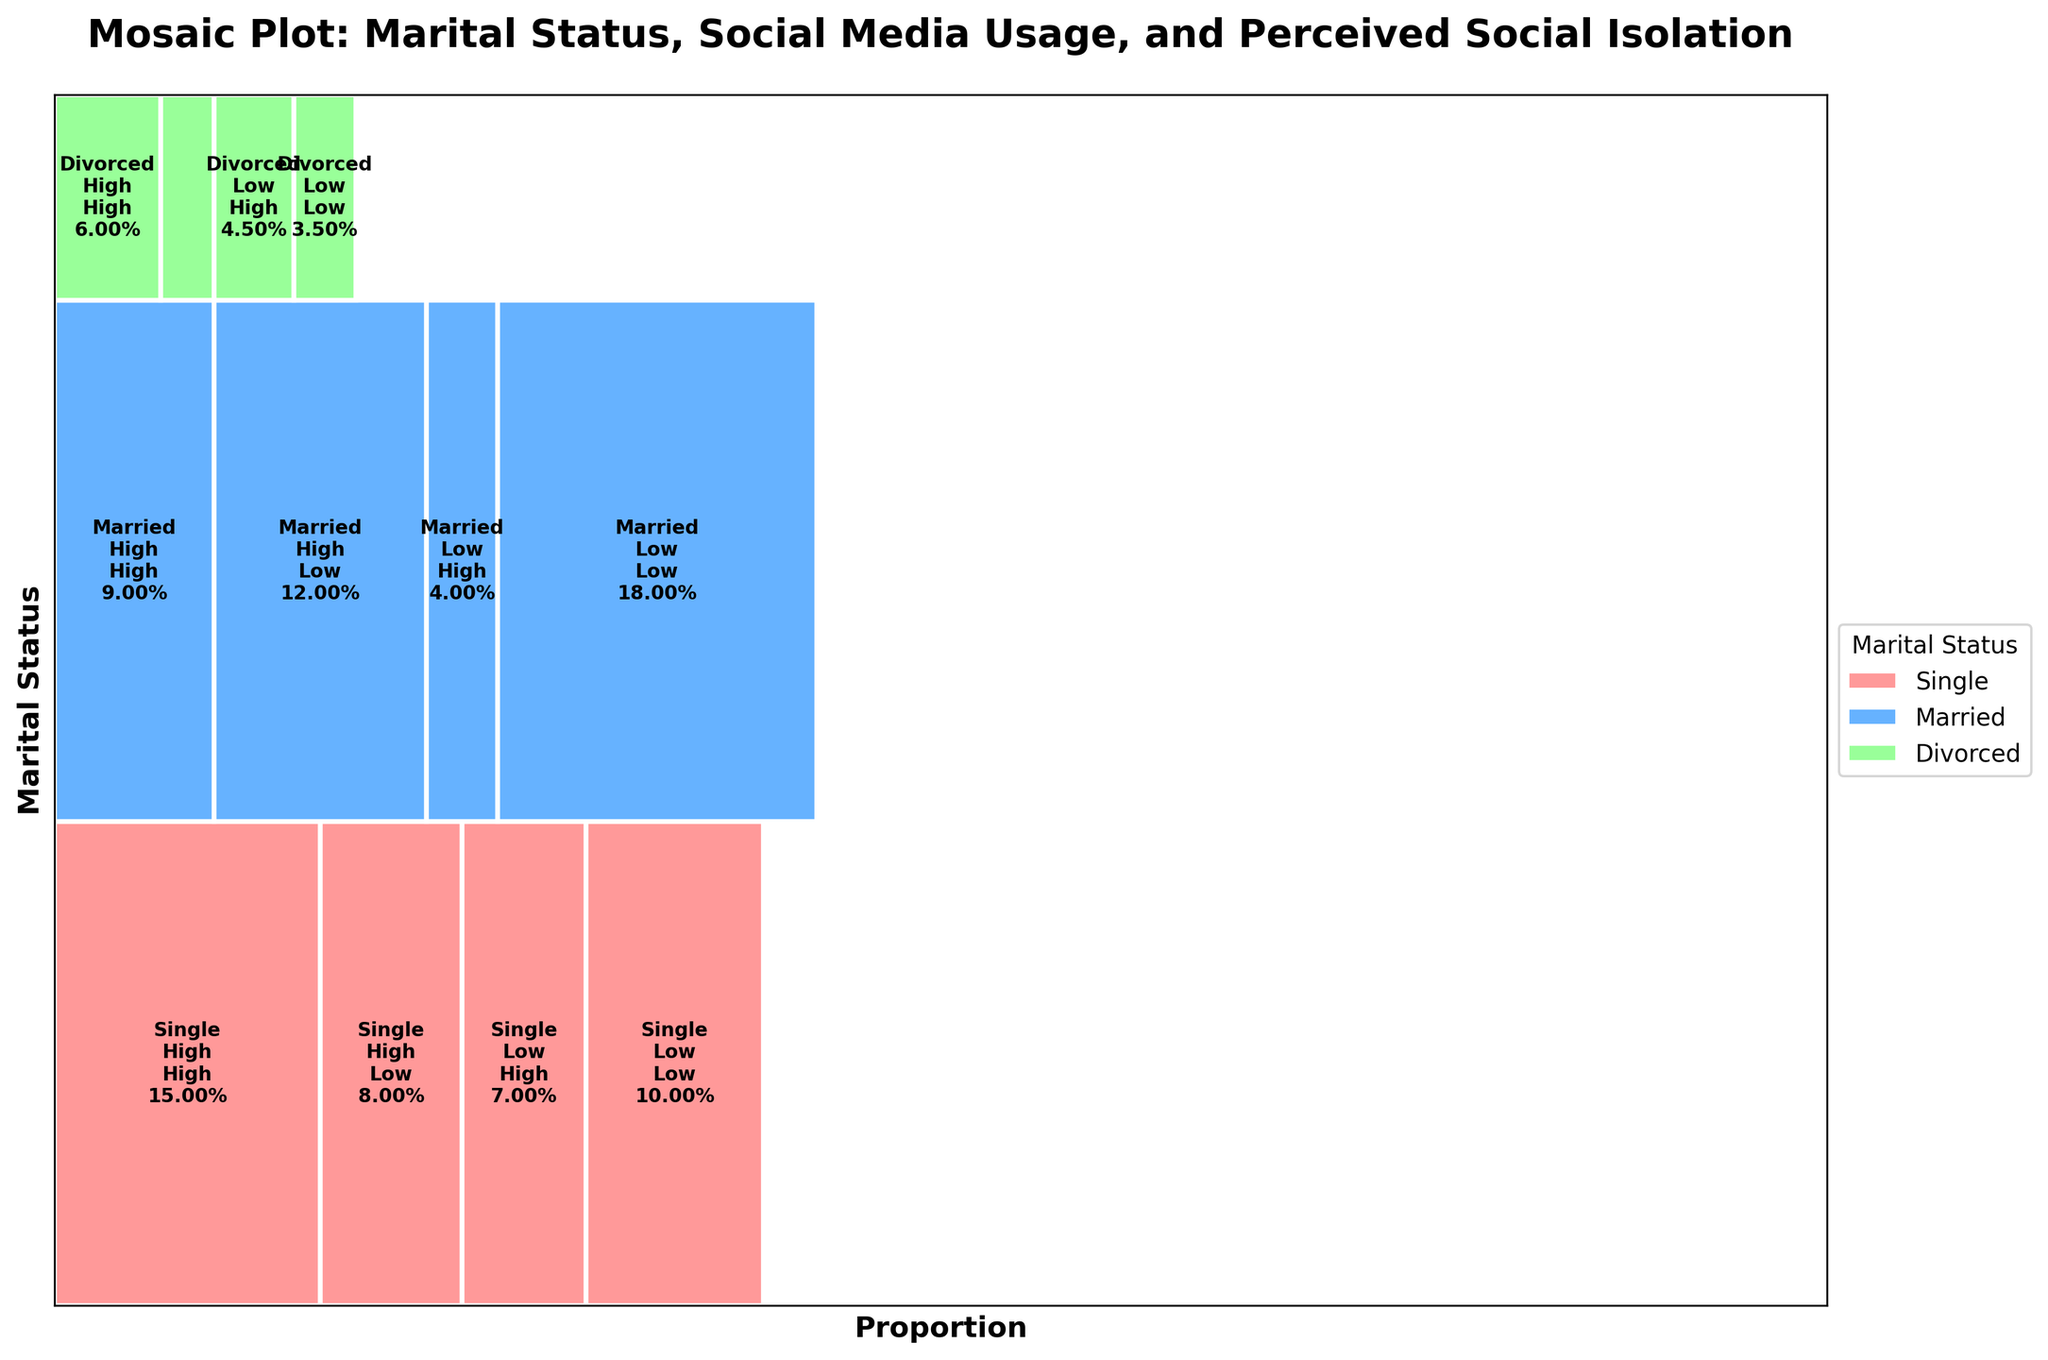What is the title of the plot? The title of the plot is displayed at the top and reads "Mosaic Plot: Marital Status, Social Media Usage, and Perceived Social Isolation".
Answer: Mosaic Plot: Marital Status, Social Media Usage, and Perceived Social Isolation How many different marital statuses are shown in the plot? The plot categorizes the data into three different marital statuses: Single, Married, and Divorced. The colors represent these categories.
Answer: Three Which group has the highest proportion with high social media usage and high perceived social isolation? By observing the labeled rectangles, the "Single" group with high social media usage and high perceived social isolation has a larger width proportion compared to the others.
Answer: Single Between married individuals, which social media usage group perceives lower social isolation more frequently? For married individuals, the rectangles representing low isolation have bigger proportions for low social media usage compared to high social media usage.
Answer: Low social media usage Compare the width of the "Divorced" group with low social media usage and low perceived social isolation to the "Married" group with high social media usage and low perceived social isolation. Which is wider? The proportion of the rectangle for divorced individuals with low social media usage and low isolation is smaller than that for married individuals with high social media usage and low isolation.
Answer: Married, high social media usage, low isolation What proportion of single individuals perceive high social isolation regardless of their social media usage? Combine the widths of the rectangles showing high perceived social isolation for both high and low social media usage in the "Single" category. The sum is larger than for the low perceived isolation counterparts in the same category.
Answer: 22% Which marital status has the smallest proportion of individuals with low social media usage and high perceived social isolation? By comparing the rectangles, divorced individuals with low social media usage and high perceived social isolation have the smallest width.
Answer: Divorced For the "Married" group, what’s the difference in proportion between low and high perceived social isolation for those using social media highly? For married individuals with high social media usage, subtract the width of the low isolation rectangle from the high isolation rectangle to get the difference.
Answer: -0.01 (1% less high perceived social isolation for high social media usage) Does the plot indicate more overall perceived social isolation in single or divorced individuals? By comparing the total width of rectangles for high isolation in the single and divorced categories, the single group has more overall perceived social isolation.
Answer: Single 